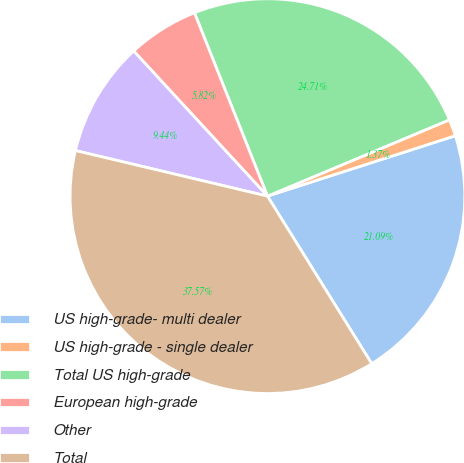Convert chart to OTSL. <chart><loc_0><loc_0><loc_500><loc_500><pie_chart><fcel>US high-grade- multi dealer<fcel>US high-grade - single dealer<fcel>Total US high-grade<fcel>European high-grade<fcel>Other<fcel>Total<nl><fcel>21.09%<fcel>1.37%<fcel>24.71%<fcel>5.82%<fcel>9.44%<fcel>37.57%<nl></chart> 